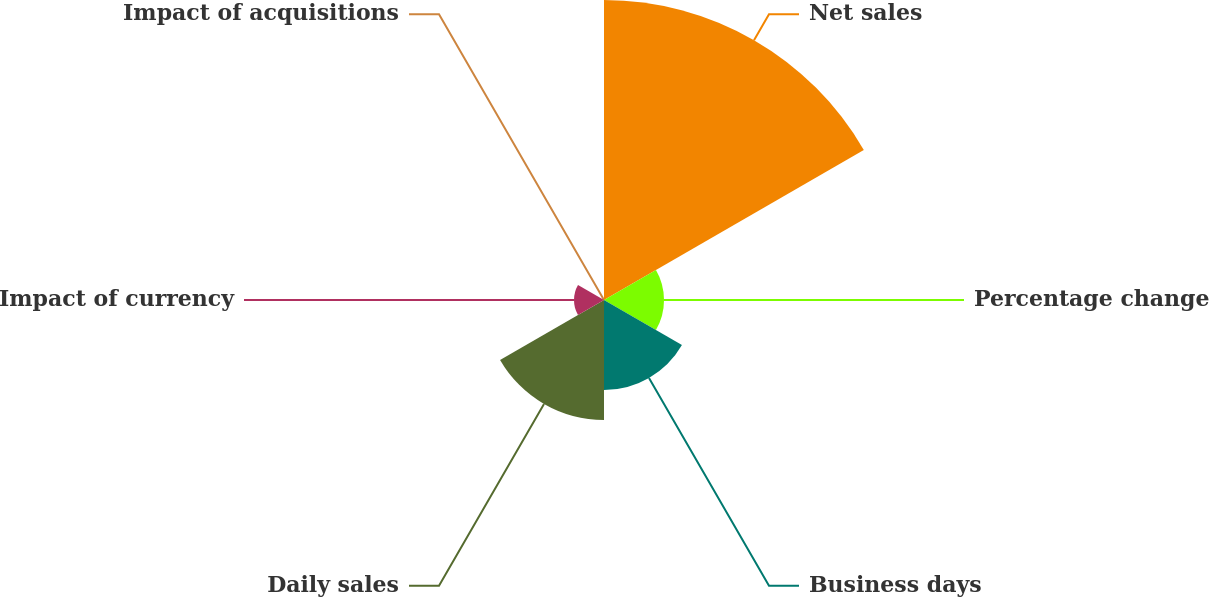Convert chart. <chart><loc_0><loc_0><loc_500><loc_500><pie_chart><fcel>Net sales<fcel>Percentage change<fcel>Business days<fcel>Daily sales<fcel>Impact of currency<fcel>Impact of acquisitions<nl><fcel>50.0%<fcel>10.0%<fcel>15.0%<fcel>20.0%<fcel>5.0%<fcel>0.0%<nl></chart> 